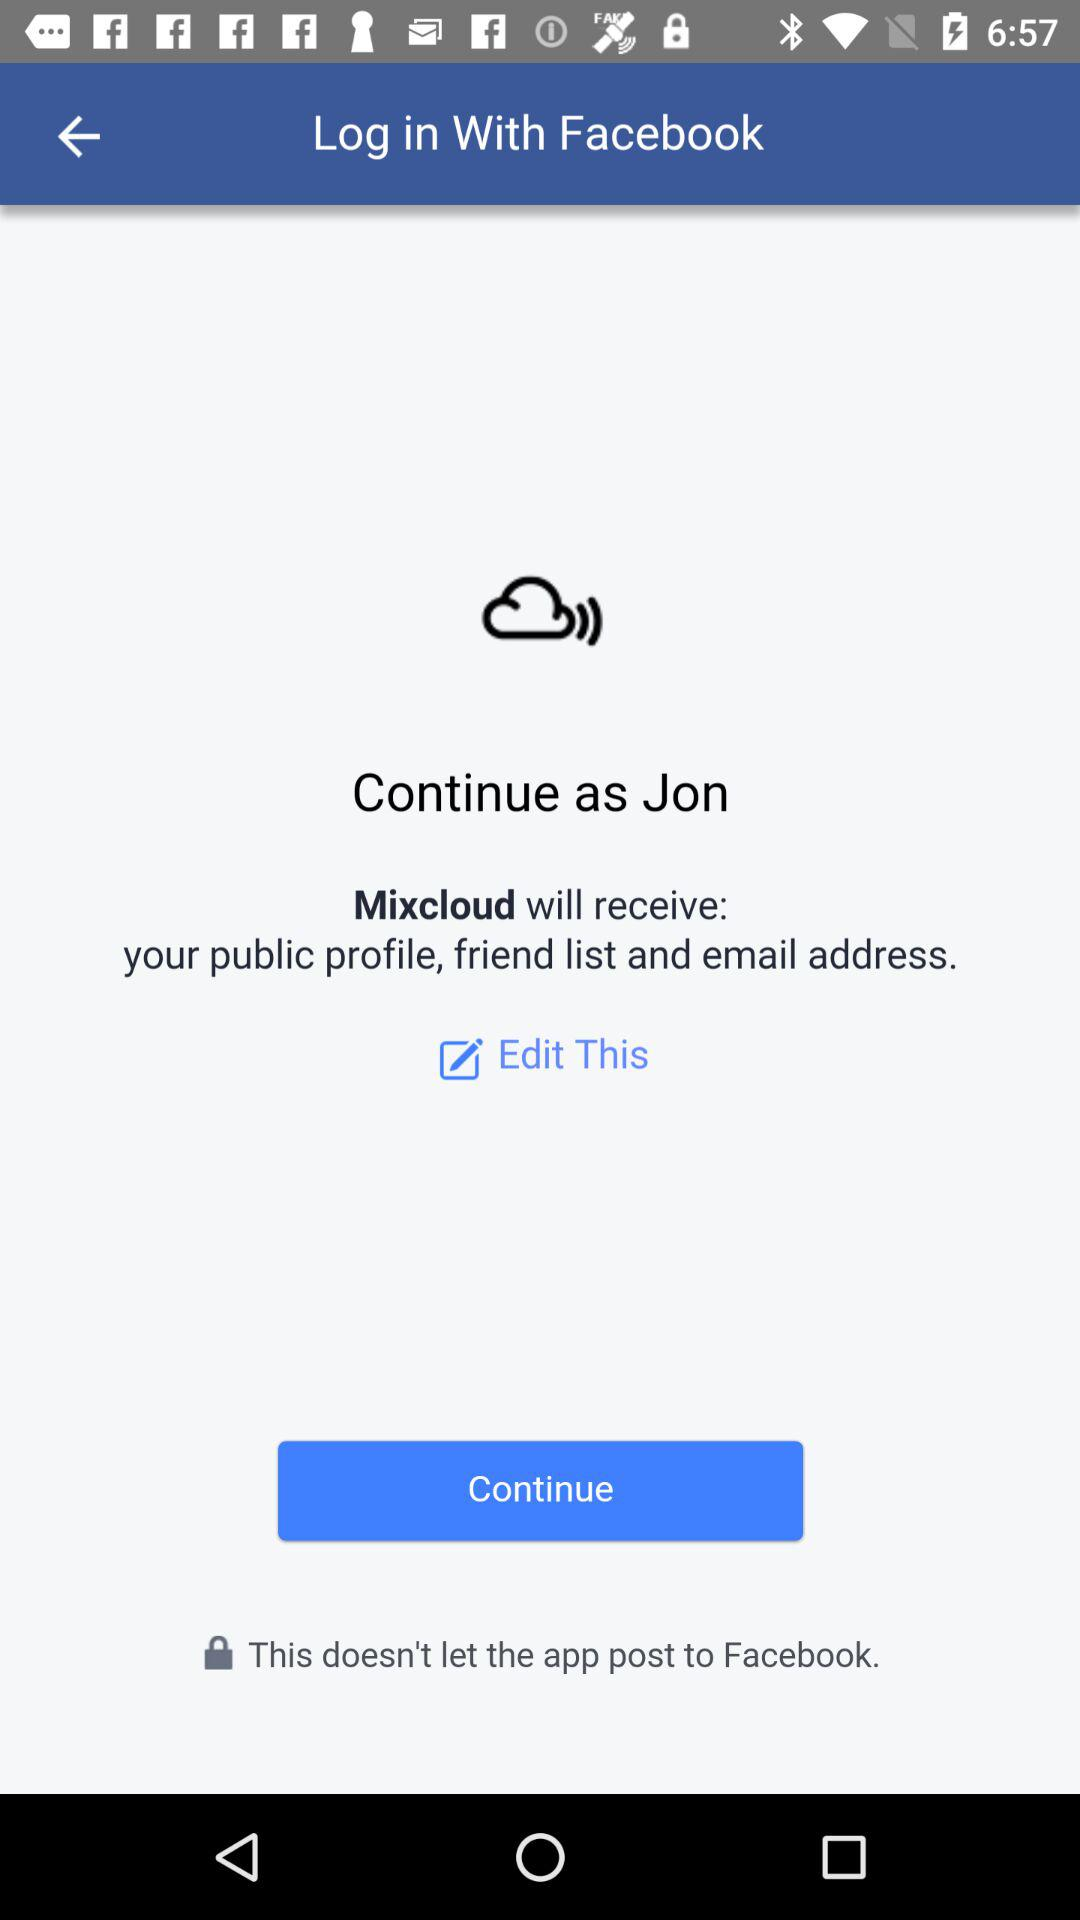Through what applications can we log in? You can log in through "Facebook". 